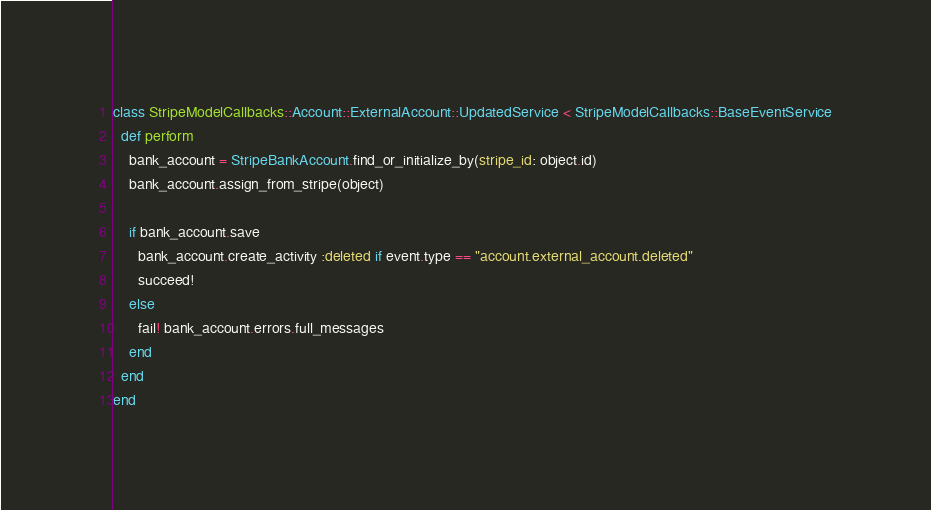<code> <loc_0><loc_0><loc_500><loc_500><_Ruby_>class StripeModelCallbacks::Account::ExternalAccount::UpdatedService < StripeModelCallbacks::BaseEventService
  def perform
    bank_account = StripeBankAccount.find_or_initialize_by(stripe_id: object.id)
    bank_account.assign_from_stripe(object)

    if bank_account.save
      bank_account.create_activity :deleted if event.type == "account.external_account.deleted"
      succeed!
    else
      fail! bank_account.errors.full_messages
    end
  end
end
</code> 